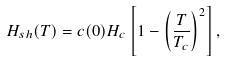Convert formula to latex. <formula><loc_0><loc_0><loc_500><loc_500>H _ { s h } ( T ) = c ( 0 ) H _ { c } \left [ 1 - \left ( \frac { T } { T _ { c } } \right ) ^ { 2 } \right ] ,</formula> 